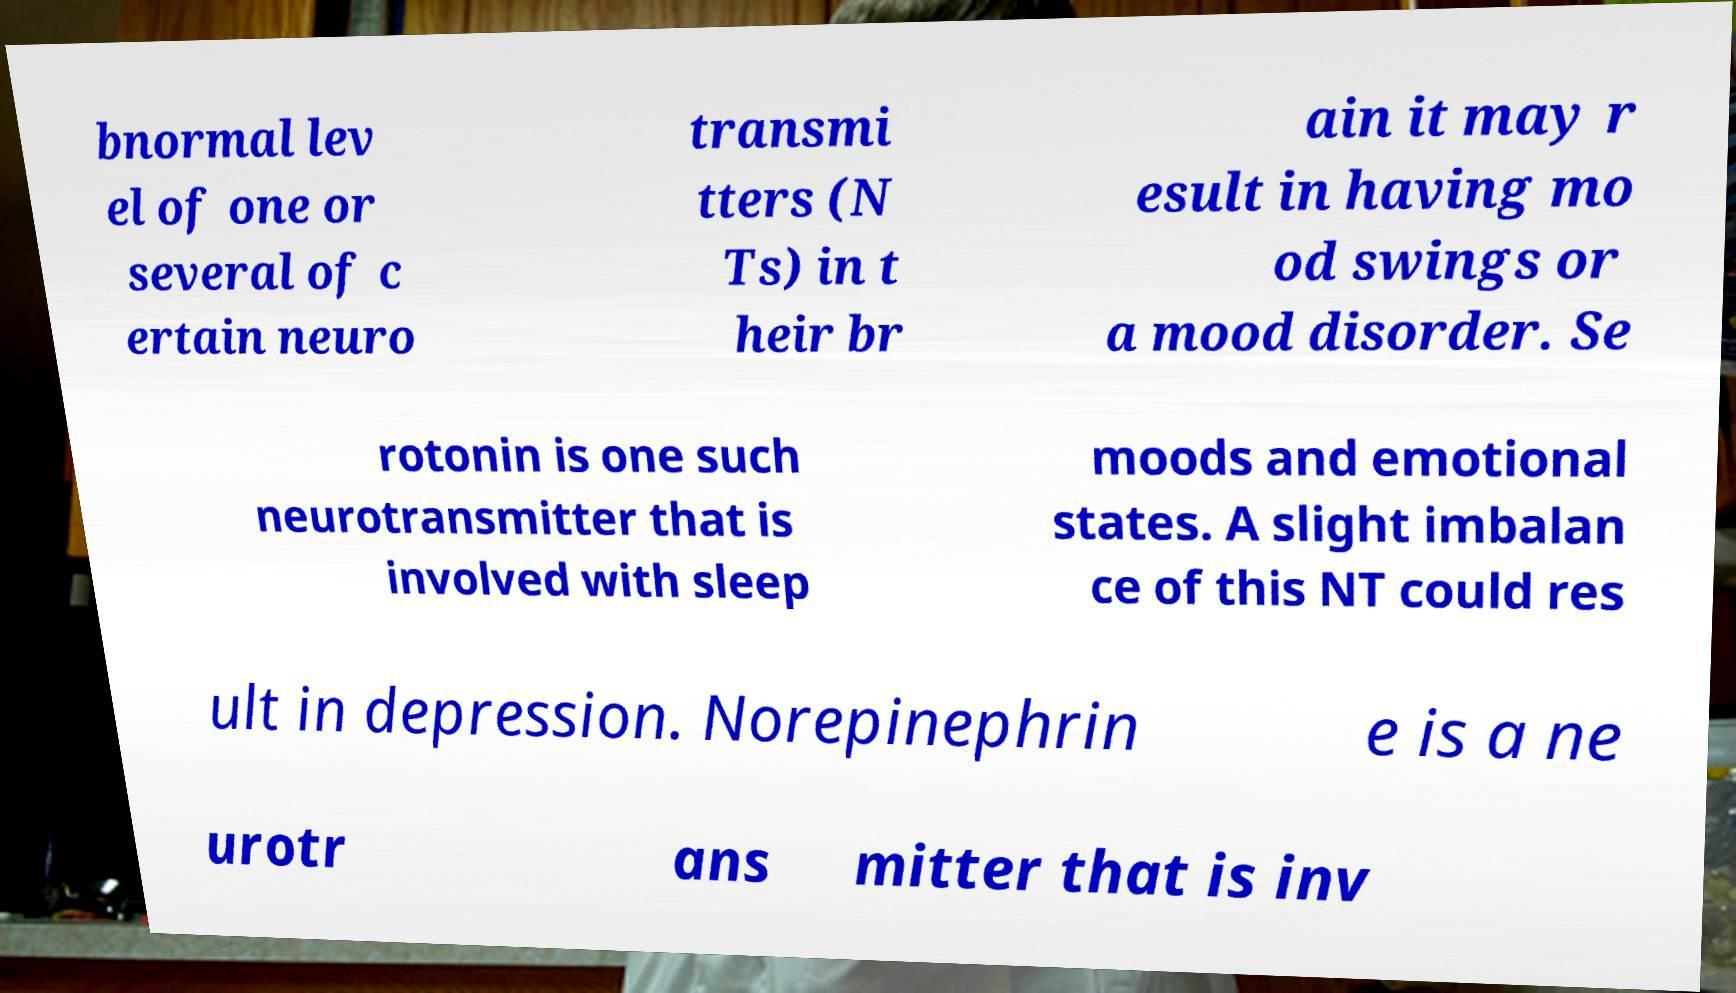There's text embedded in this image that I need extracted. Can you transcribe it verbatim? bnormal lev el of one or several of c ertain neuro transmi tters (N Ts) in t heir br ain it may r esult in having mo od swings or a mood disorder. Se rotonin is one such neurotransmitter that is involved with sleep moods and emotional states. A slight imbalan ce of this NT could res ult in depression. Norepinephrin e is a ne urotr ans mitter that is inv 